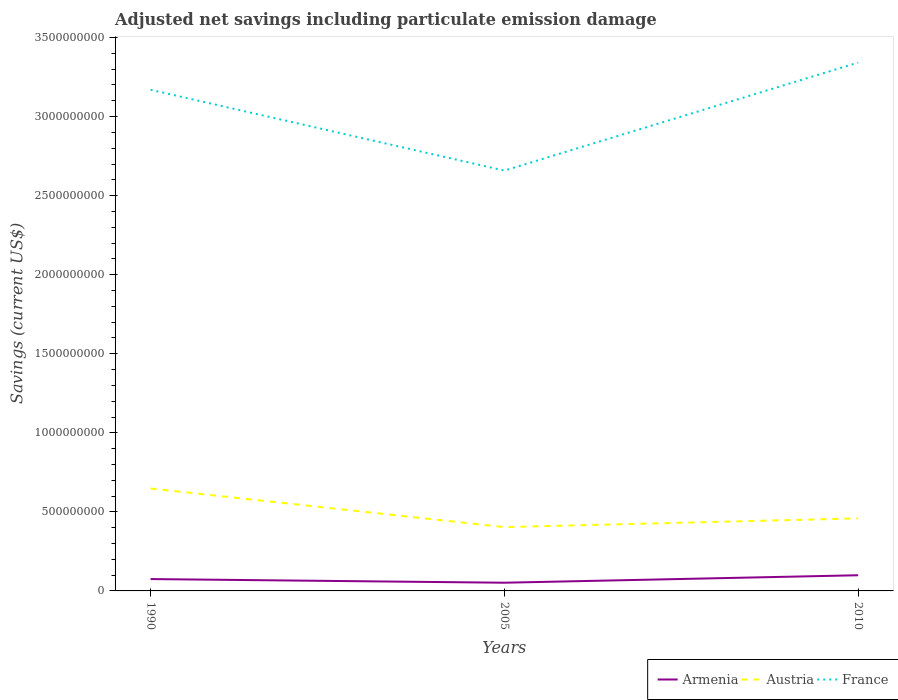Does the line corresponding to Austria intersect with the line corresponding to France?
Make the answer very short. No. Is the number of lines equal to the number of legend labels?
Your answer should be compact. Yes. Across all years, what is the maximum net savings in Austria?
Provide a short and direct response. 4.04e+08. In which year was the net savings in Armenia maximum?
Your answer should be compact. 2005. What is the total net savings in Armenia in the graph?
Offer a terse response. 2.32e+07. What is the difference between the highest and the second highest net savings in Armenia?
Offer a terse response. 4.72e+07. What is the difference between the highest and the lowest net savings in Armenia?
Offer a terse response. 1. What is the difference between two consecutive major ticks on the Y-axis?
Your answer should be very brief. 5.00e+08. Does the graph contain any zero values?
Provide a succinct answer. No. Does the graph contain grids?
Your response must be concise. No. How many legend labels are there?
Your response must be concise. 3. What is the title of the graph?
Your response must be concise. Adjusted net savings including particulate emission damage. What is the label or title of the X-axis?
Ensure brevity in your answer.  Years. What is the label or title of the Y-axis?
Provide a short and direct response. Savings (current US$). What is the Savings (current US$) in Armenia in 1990?
Ensure brevity in your answer.  7.50e+07. What is the Savings (current US$) in Austria in 1990?
Ensure brevity in your answer.  6.48e+08. What is the Savings (current US$) in France in 1990?
Provide a succinct answer. 3.17e+09. What is the Savings (current US$) in Armenia in 2005?
Keep it short and to the point. 5.19e+07. What is the Savings (current US$) in Austria in 2005?
Ensure brevity in your answer.  4.04e+08. What is the Savings (current US$) in France in 2005?
Ensure brevity in your answer.  2.66e+09. What is the Savings (current US$) in Armenia in 2010?
Provide a succinct answer. 9.91e+07. What is the Savings (current US$) of Austria in 2010?
Make the answer very short. 4.59e+08. What is the Savings (current US$) in France in 2010?
Provide a short and direct response. 3.34e+09. Across all years, what is the maximum Savings (current US$) of Armenia?
Your response must be concise. 9.91e+07. Across all years, what is the maximum Savings (current US$) of Austria?
Keep it short and to the point. 6.48e+08. Across all years, what is the maximum Savings (current US$) in France?
Keep it short and to the point. 3.34e+09. Across all years, what is the minimum Savings (current US$) of Armenia?
Offer a terse response. 5.19e+07. Across all years, what is the minimum Savings (current US$) of Austria?
Make the answer very short. 4.04e+08. Across all years, what is the minimum Savings (current US$) of France?
Your response must be concise. 2.66e+09. What is the total Savings (current US$) in Armenia in the graph?
Offer a very short reply. 2.26e+08. What is the total Savings (current US$) of Austria in the graph?
Your answer should be very brief. 1.51e+09. What is the total Savings (current US$) of France in the graph?
Offer a terse response. 9.17e+09. What is the difference between the Savings (current US$) in Armenia in 1990 and that in 2005?
Your answer should be very brief. 2.32e+07. What is the difference between the Savings (current US$) of Austria in 1990 and that in 2005?
Your answer should be compact. 2.44e+08. What is the difference between the Savings (current US$) in France in 1990 and that in 2005?
Your answer should be very brief. 5.11e+08. What is the difference between the Savings (current US$) in Armenia in 1990 and that in 2010?
Keep it short and to the point. -2.41e+07. What is the difference between the Savings (current US$) in Austria in 1990 and that in 2010?
Ensure brevity in your answer.  1.89e+08. What is the difference between the Savings (current US$) in France in 1990 and that in 2010?
Your answer should be very brief. -1.72e+08. What is the difference between the Savings (current US$) of Armenia in 2005 and that in 2010?
Ensure brevity in your answer.  -4.72e+07. What is the difference between the Savings (current US$) of Austria in 2005 and that in 2010?
Offer a terse response. -5.51e+07. What is the difference between the Savings (current US$) of France in 2005 and that in 2010?
Ensure brevity in your answer.  -6.83e+08. What is the difference between the Savings (current US$) of Armenia in 1990 and the Savings (current US$) of Austria in 2005?
Offer a very short reply. -3.29e+08. What is the difference between the Savings (current US$) of Armenia in 1990 and the Savings (current US$) of France in 2005?
Give a very brief answer. -2.58e+09. What is the difference between the Savings (current US$) in Austria in 1990 and the Savings (current US$) in France in 2005?
Ensure brevity in your answer.  -2.01e+09. What is the difference between the Savings (current US$) of Armenia in 1990 and the Savings (current US$) of Austria in 2010?
Give a very brief answer. -3.84e+08. What is the difference between the Savings (current US$) in Armenia in 1990 and the Savings (current US$) in France in 2010?
Keep it short and to the point. -3.27e+09. What is the difference between the Savings (current US$) in Austria in 1990 and the Savings (current US$) in France in 2010?
Provide a short and direct response. -2.69e+09. What is the difference between the Savings (current US$) in Armenia in 2005 and the Savings (current US$) in Austria in 2010?
Keep it short and to the point. -4.07e+08. What is the difference between the Savings (current US$) in Armenia in 2005 and the Savings (current US$) in France in 2010?
Keep it short and to the point. -3.29e+09. What is the difference between the Savings (current US$) in Austria in 2005 and the Savings (current US$) in France in 2010?
Your answer should be very brief. -2.94e+09. What is the average Savings (current US$) of Armenia per year?
Keep it short and to the point. 7.53e+07. What is the average Savings (current US$) in Austria per year?
Give a very brief answer. 5.03e+08. What is the average Savings (current US$) of France per year?
Your answer should be very brief. 3.06e+09. In the year 1990, what is the difference between the Savings (current US$) in Armenia and Savings (current US$) in Austria?
Your answer should be very brief. -5.73e+08. In the year 1990, what is the difference between the Savings (current US$) of Armenia and Savings (current US$) of France?
Ensure brevity in your answer.  -3.09e+09. In the year 1990, what is the difference between the Savings (current US$) in Austria and Savings (current US$) in France?
Provide a short and direct response. -2.52e+09. In the year 2005, what is the difference between the Savings (current US$) of Armenia and Savings (current US$) of Austria?
Offer a very short reply. -3.52e+08. In the year 2005, what is the difference between the Savings (current US$) in Armenia and Savings (current US$) in France?
Your answer should be compact. -2.61e+09. In the year 2005, what is the difference between the Savings (current US$) of Austria and Savings (current US$) of France?
Keep it short and to the point. -2.25e+09. In the year 2010, what is the difference between the Savings (current US$) of Armenia and Savings (current US$) of Austria?
Keep it short and to the point. -3.60e+08. In the year 2010, what is the difference between the Savings (current US$) of Armenia and Savings (current US$) of France?
Your answer should be compact. -3.24e+09. In the year 2010, what is the difference between the Savings (current US$) of Austria and Savings (current US$) of France?
Your response must be concise. -2.88e+09. What is the ratio of the Savings (current US$) of Armenia in 1990 to that in 2005?
Keep it short and to the point. 1.45. What is the ratio of the Savings (current US$) of Austria in 1990 to that in 2005?
Ensure brevity in your answer.  1.6. What is the ratio of the Savings (current US$) of France in 1990 to that in 2005?
Your answer should be very brief. 1.19. What is the ratio of the Savings (current US$) of Armenia in 1990 to that in 2010?
Provide a short and direct response. 0.76. What is the ratio of the Savings (current US$) of Austria in 1990 to that in 2010?
Ensure brevity in your answer.  1.41. What is the ratio of the Savings (current US$) in France in 1990 to that in 2010?
Offer a terse response. 0.95. What is the ratio of the Savings (current US$) of Armenia in 2005 to that in 2010?
Provide a succinct answer. 0.52. What is the ratio of the Savings (current US$) of Austria in 2005 to that in 2010?
Your response must be concise. 0.88. What is the ratio of the Savings (current US$) in France in 2005 to that in 2010?
Give a very brief answer. 0.8. What is the difference between the highest and the second highest Savings (current US$) of Armenia?
Keep it short and to the point. 2.41e+07. What is the difference between the highest and the second highest Savings (current US$) of Austria?
Give a very brief answer. 1.89e+08. What is the difference between the highest and the second highest Savings (current US$) of France?
Your answer should be very brief. 1.72e+08. What is the difference between the highest and the lowest Savings (current US$) in Armenia?
Your response must be concise. 4.72e+07. What is the difference between the highest and the lowest Savings (current US$) of Austria?
Give a very brief answer. 2.44e+08. What is the difference between the highest and the lowest Savings (current US$) of France?
Provide a short and direct response. 6.83e+08. 